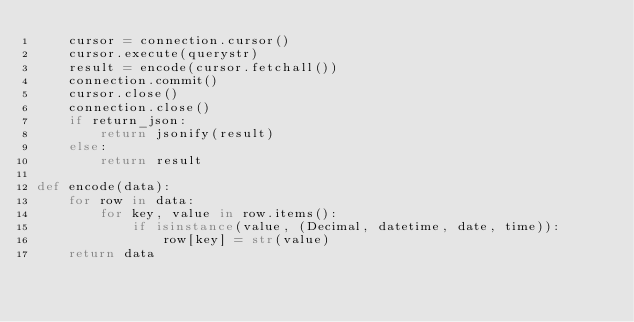Convert code to text. <code><loc_0><loc_0><loc_500><loc_500><_Python_>    cursor = connection.cursor()
    cursor.execute(querystr)
    result = encode(cursor.fetchall())
    connection.commit()
    cursor.close()
    connection.close()
    if return_json:
        return jsonify(result)
    else:
        return result

def encode(data):
    for row in data:
        for key, value in row.items():
            if isinstance(value, (Decimal, datetime, date, time)):
                row[key] = str(value)
    return data</code> 